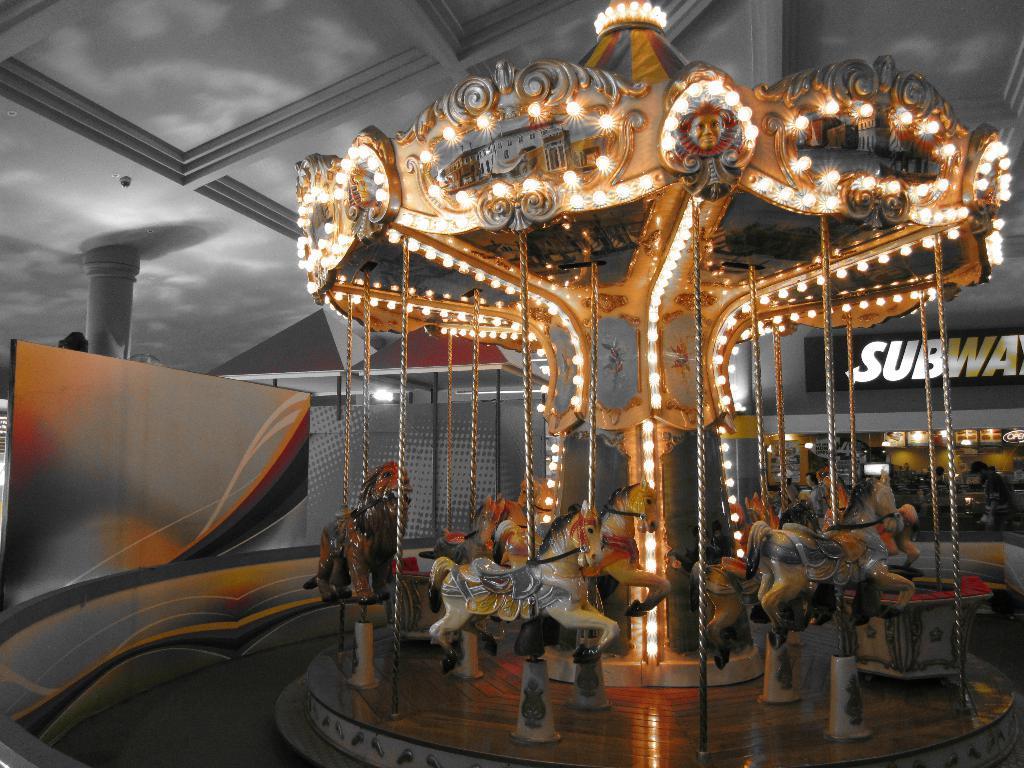In one or two sentences, can you explain what this image depicts? In this image I see the merry-go-round and I see the lights and I see a word written over here and I see the platform and it is a bit dark in the background. 